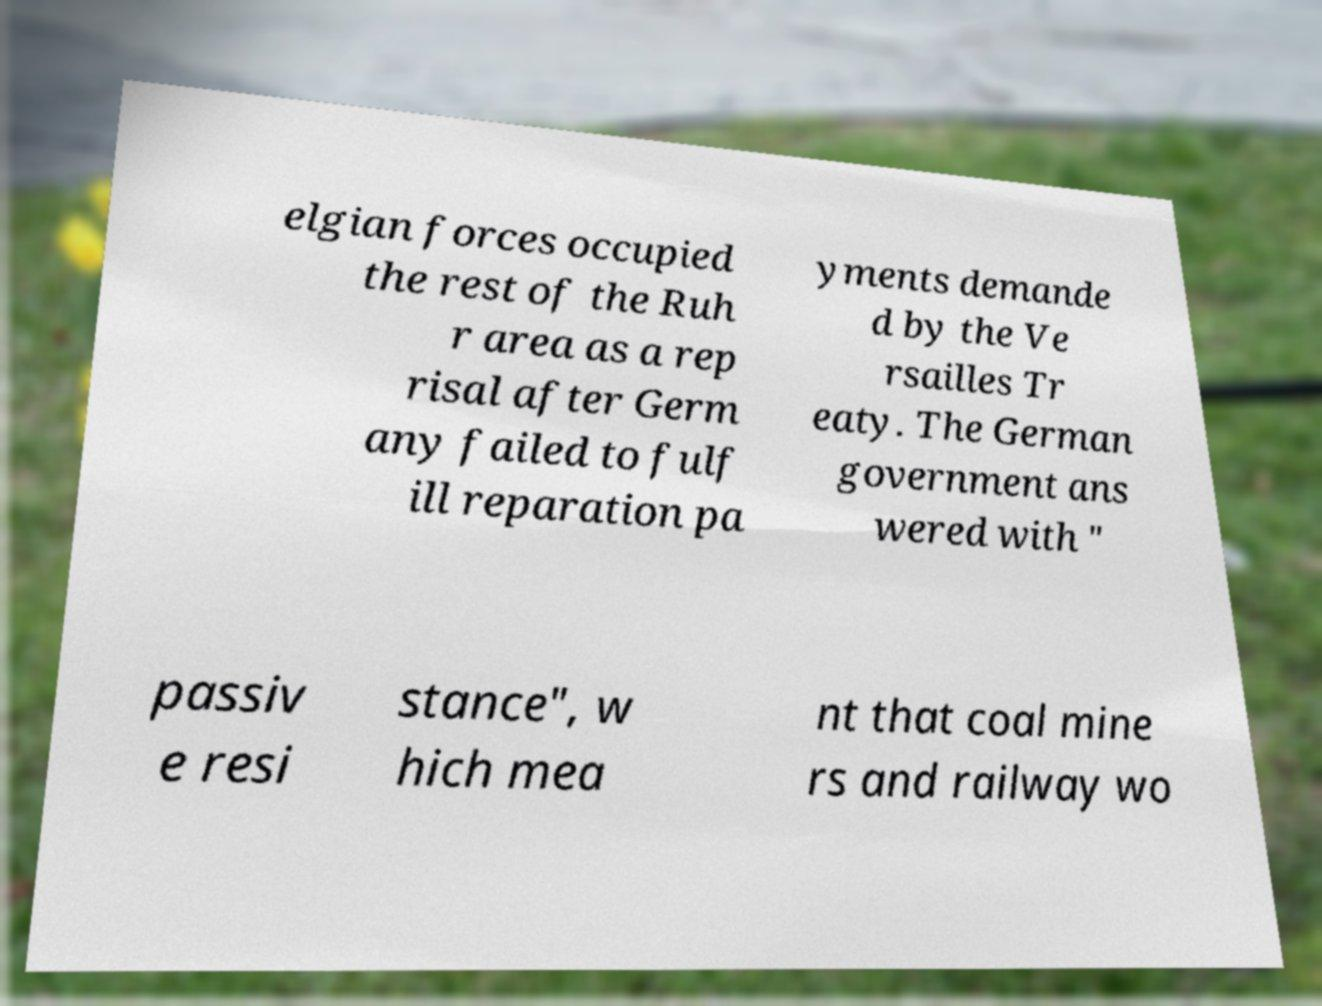Please read and relay the text visible in this image. What does it say? elgian forces occupied the rest of the Ruh r area as a rep risal after Germ any failed to fulf ill reparation pa yments demande d by the Ve rsailles Tr eaty. The German government ans wered with " passiv e resi stance", w hich mea nt that coal mine rs and railway wo 